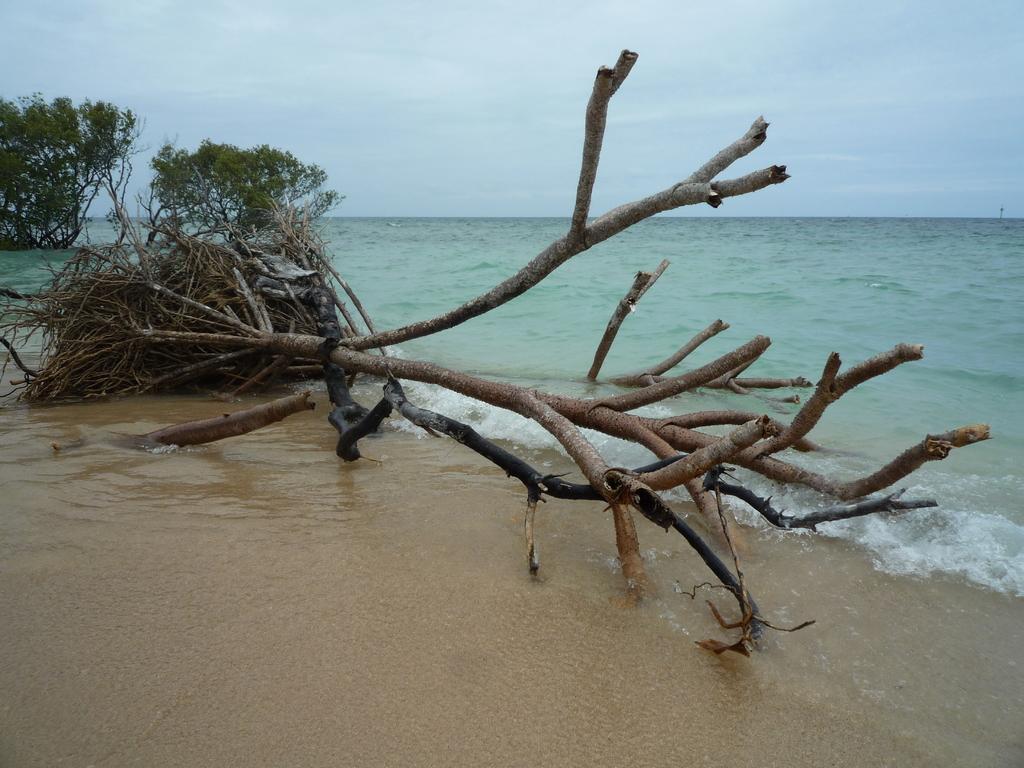How would you summarize this image in a sentence or two? In this image there is a Sea in middle of this image and there are some trees on the left side of this image. There is a ground in the bottom of this image and there is a sky on the top of this image. 